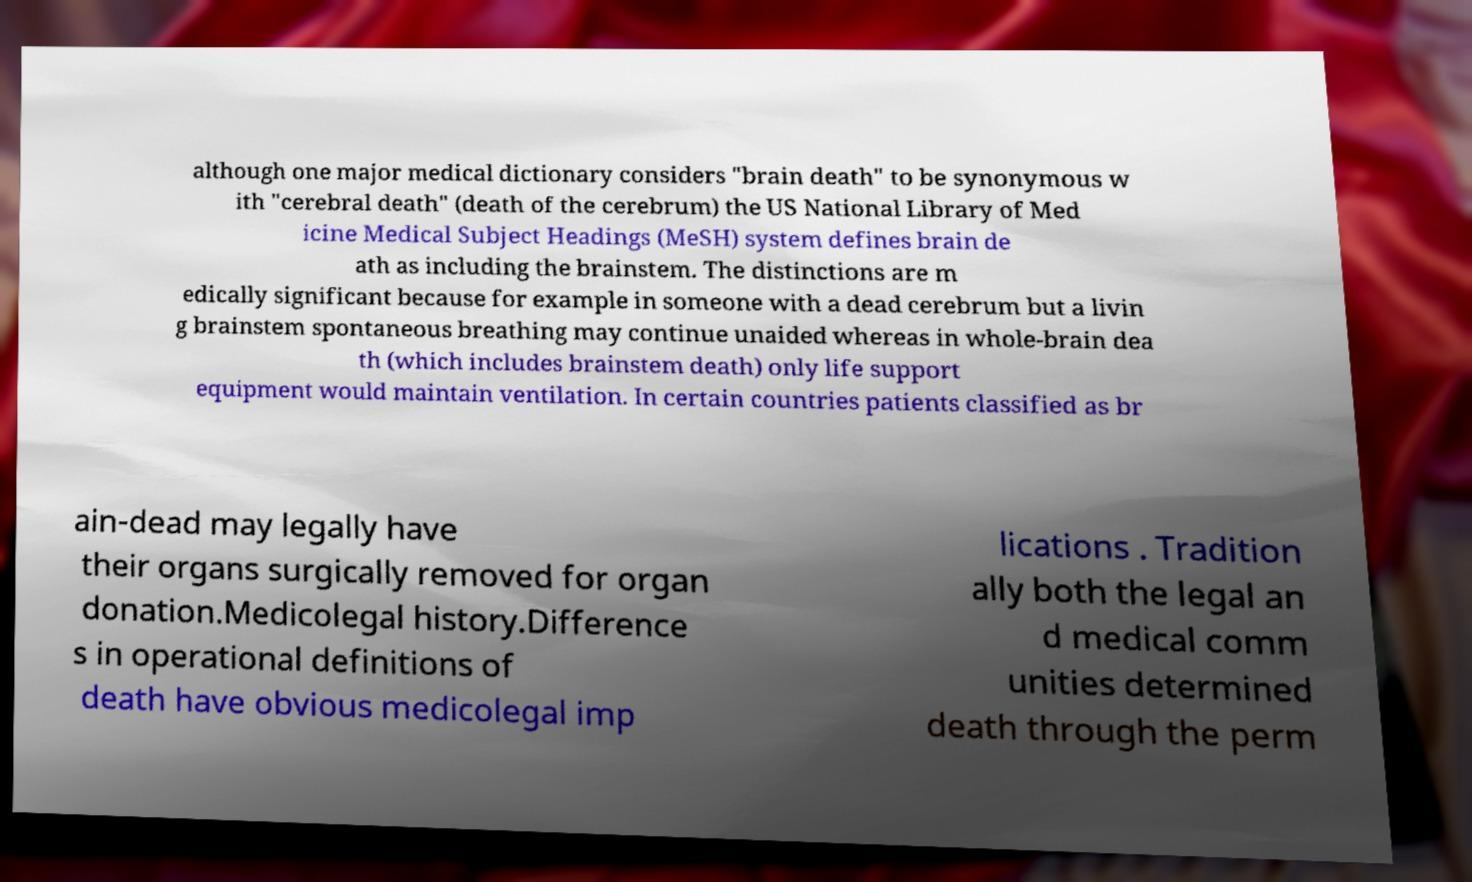What messages or text are displayed in this image? I need them in a readable, typed format. although one major medical dictionary considers "brain death" to be synonymous w ith "cerebral death" (death of the cerebrum) the US National Library of Med icine Medical Subject Headings (MeSH) system defines brain de ath as including the brainstem. The distinctions are m edically significant because for example in someone with a dead cerebrum but a livin g brainstem spontaneous breathing may continue unaided whereas in whole-brain dea th (which includes brainstem death) only life support equipment would maintain ventilation. In certain countries patients classified as br ain-dead may legally have their organs surgically removed for organ donation.Medicolegal history.Difference s in operational definitions of death have obvious medicolegal imp lications . Tradition ally both the legal an d medical comm unities determined death through the perm 